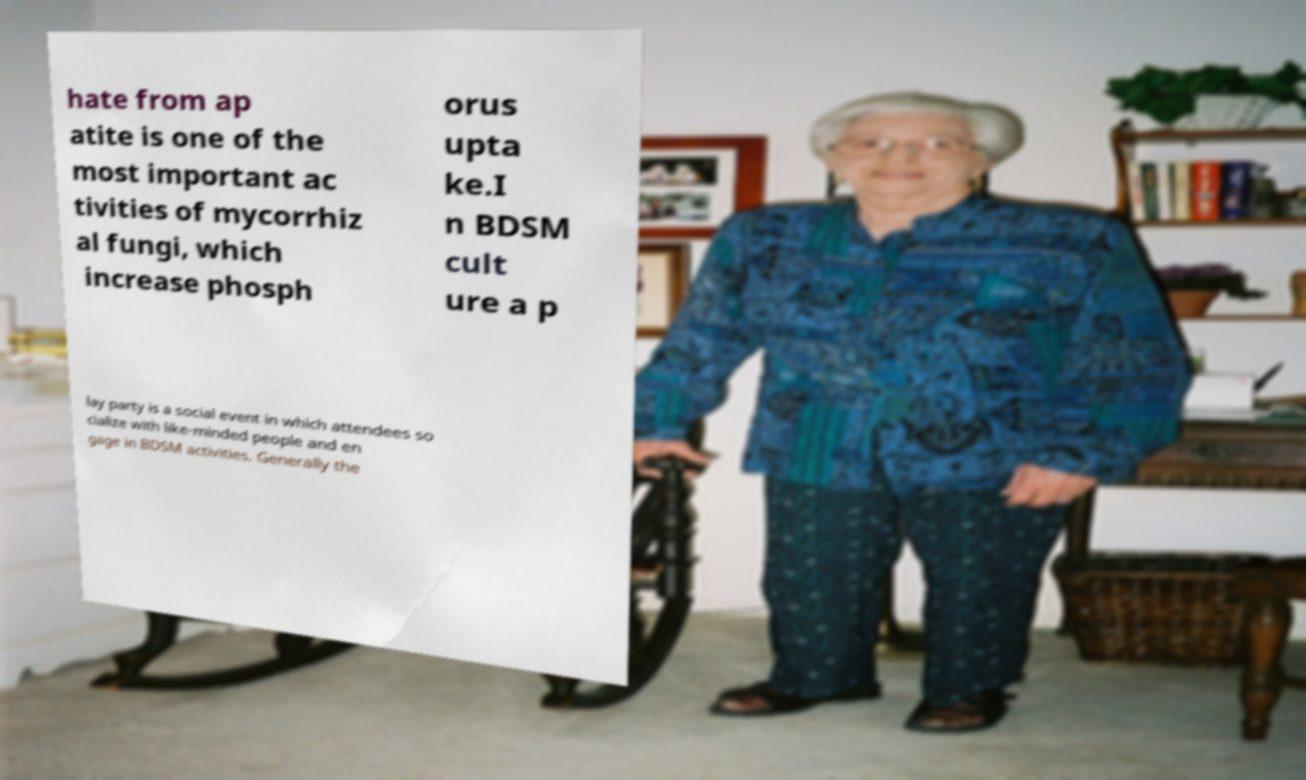I need the written content from this picture converted into text. Can you do that? hate from ap atite is one of the most important ac tivities of mycorrhiz al fungi, which increase phosph orus upta ke.I n BDSM cult ure a p lay party is a social event in which attendees so cialize with like-minded people and en gage in BDSM activities. Generally the 